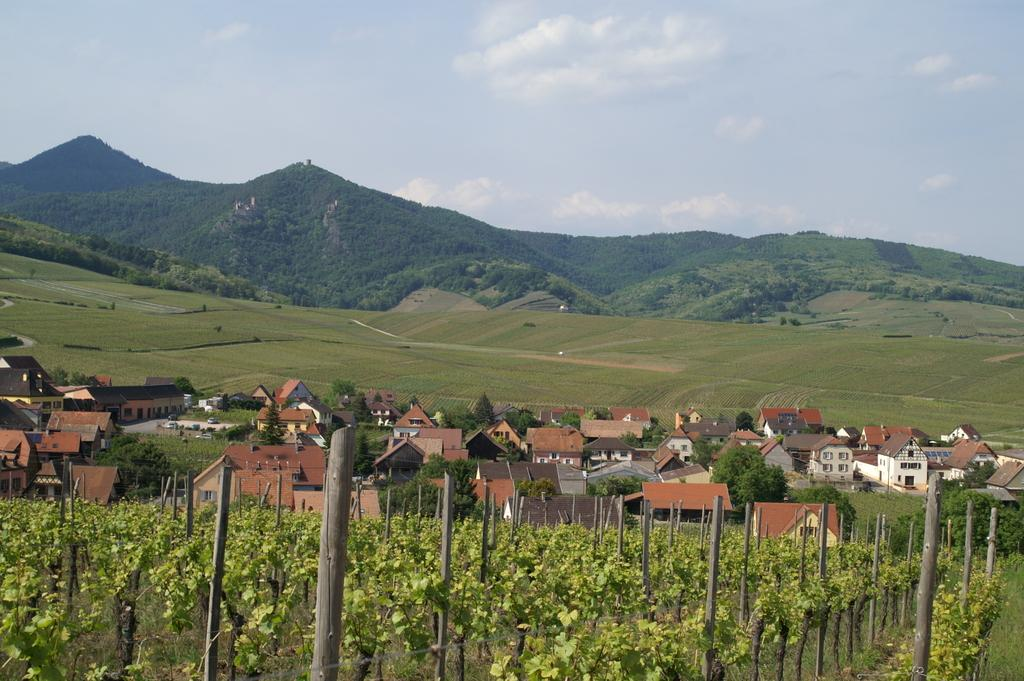What type of vegetation can be seen in the image? There are trees and plants in the image. What type of terrain is visible in the image? There are hills in the image. What is the color and condition of the sky in the image? The sky is blue and cloudy in the image. What type of structures are present in the image? There are houses in the image. What type of ground cover is visible in the image? There is grass on the ground in the image. What date is marked on the calendar in the image? There is no calendar present in the image. What type of rodent can be seen interacting with the plants in the image? There is no rodent present in the image; only trees, plants, hills, houses, and grass are visible. 